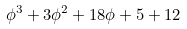Convert formula to latex. <formula><loc_0><loc_0><loc_500><loc_500>\phi ^ { 3 } + 3 \phi ^ { 2 } + 1 8 \phi + 5 + 1 2</formula> 